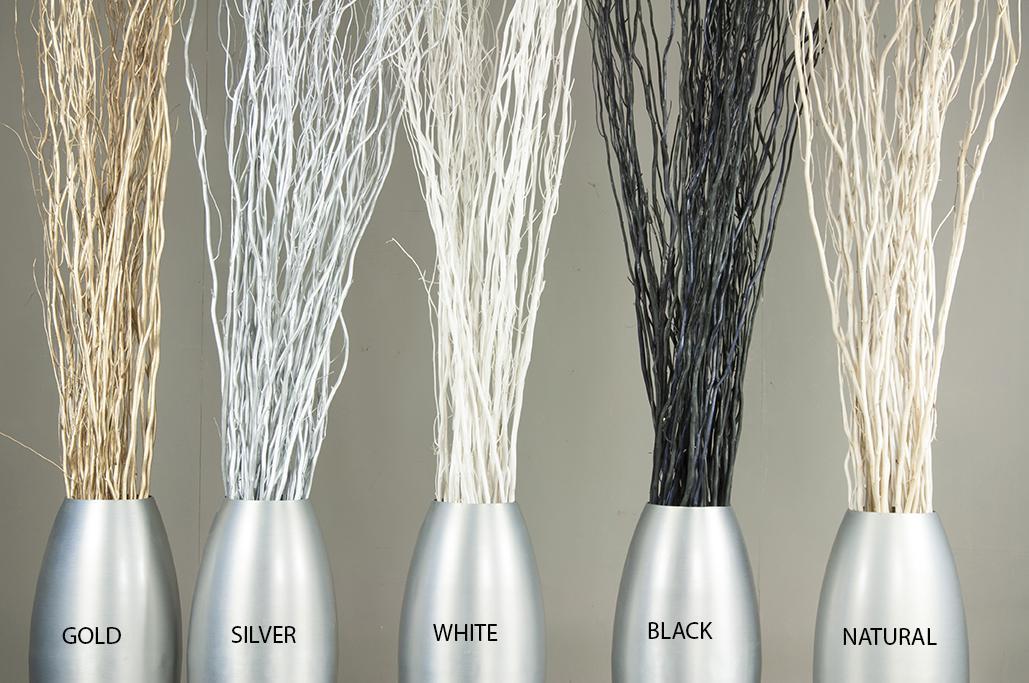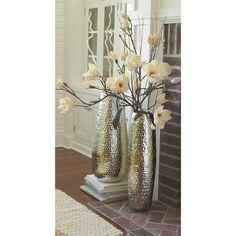The first image is the image on the left, the second image is the image on the right. Analyze the images presented: Is the assertion "there is one vase on the right image" valid? Answer yes or no. No. 